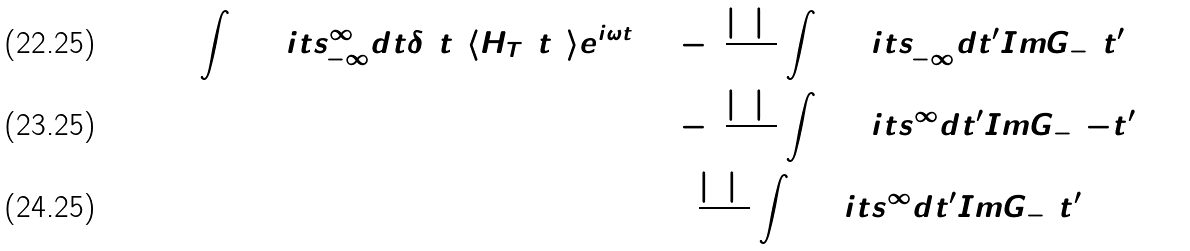Convert formula to latex. <formula><loc_0><loc_0><loc_500><loc_500>\int \lim i t s _ { - \infty } ^ { \infty } d t \delta ( t ) \langle H _ { T } ( t ) \rangle e ^ { i \omega t } & = - 4 \frac { | \Gamma | ^ { 2 } } { } \int \lim i t s _ { - \infty } ^ { 0 } d t ^ { \prime } I m G _ { - } ( t ^ { \prime } ; 0 ) \\ & = - 4 \frac { | \Gamma | ^ { 2 } } { } \int \lim i t s _ { 0 } ^ { \infty } d t ^ { \prime } I m G _ { - } ( - t ^ { \prime } ; 0 ) \\ & = 4 \frac { | \Gamma | ^ { 2 } } { } \int \lim i t s _ { 0 } ^ { \infty } d t ^ { \prime } I m G _ { - } ( t ^ { \prime } ; 0 )</formula> 